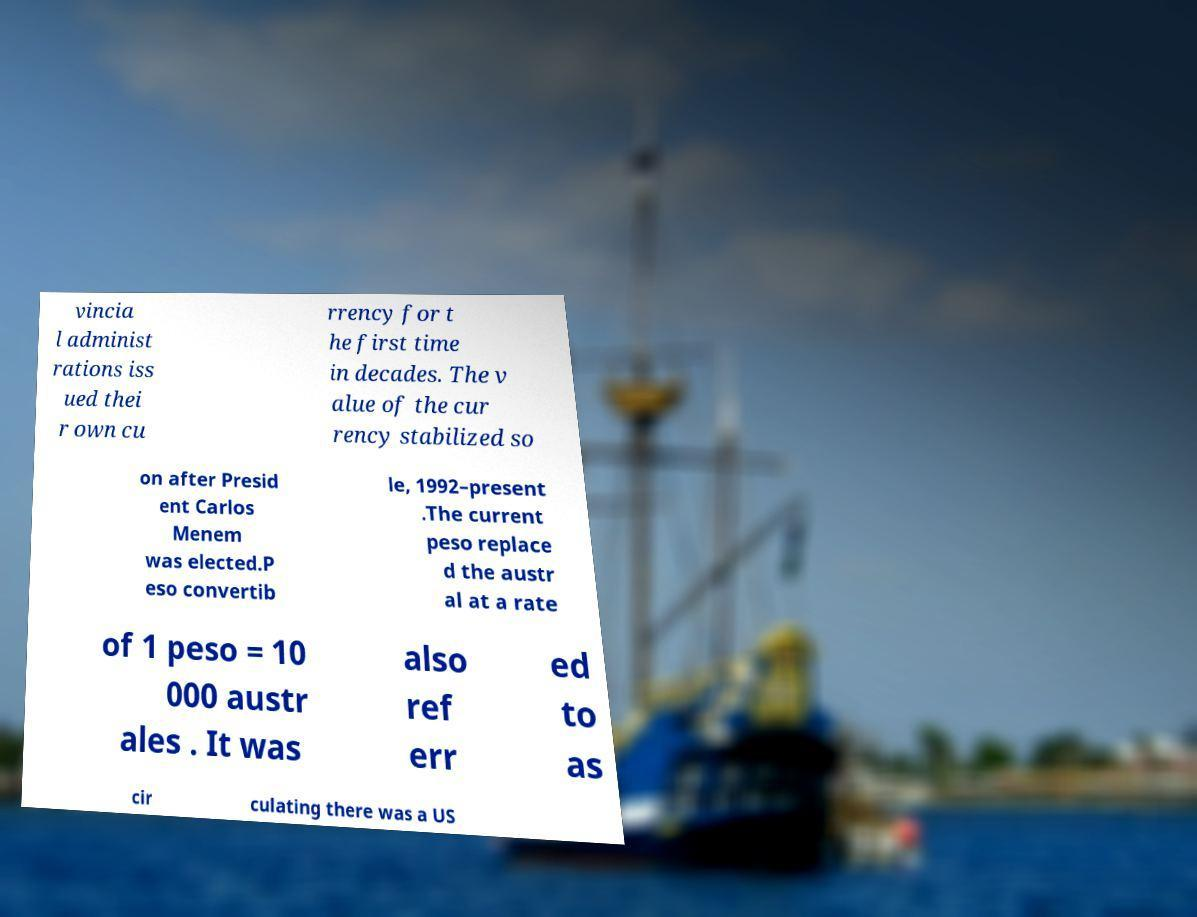What messages or text are displayed in this image? I need them in a readable, typed format. vincia l administ rations iss ued thei r own cu rrency for t he first time in decades. The v alue of the cur rency stabilized so on after Presid ent Carlos Menem was elected.P eso convertib le, 1992–present .The current peso replace d the austr al at a rate of 1 peso = 10 000 austr ales . It was also ref err ed to as cir culating there was a US 